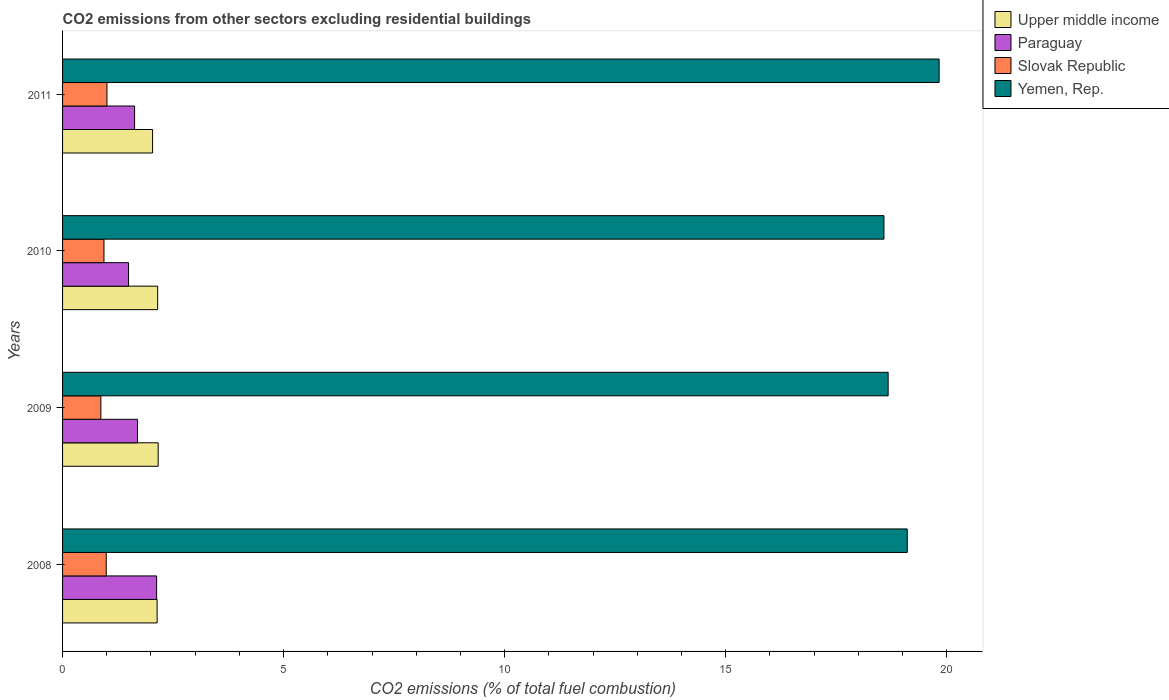Are the number of bars per tick equal to the number of legend labels?
Give a very brief answer. Yes. Are the number of bars on each tick of the Y-axis equal?
Provide a succinct answer. Yes. How many bars are there on the 1st tick from the top?
Keep it short and to the point. 4. How many bars are there on the 2nd tick from the bottom?
Keep it short and to the point. 4. What is the total CO2 emitted in Yemen, Rep. in 2009?
Provide a succinct answer. 18.68. Across all years, what is the maximum total CO2 emitted in Upper middle income?
Give a very brief answer. 2.16. Across all years, what is the minimum total CO2 emitted in Yemen, Rep.?
Make the answer very short. 18.58. In which year was the total CO2 emitted in Paraguay maximum?
Your response must be concise. 2008. What is the total total CO2 emitted in Slovak Republic in the graph?
Give a very brief answer. 3.79. What is the difference between the total CO2 emitted in Slovak Republic in 2010 and that in 2011?
Provide a short and direct response. -0.07. What is the difference between the total CO2 emitted in Upper middle income in 2010 and the total CO2 emitted in Paraguay in 2011?
Your response must be concise. 0.52. What is the average total CO2 emitted in Upper middle income per year?
Your answer should be compact. 2.12. In the year 2009, what is the difference between the total CO2 emitted in Paraguay and total CO2 emitted in Yemen, Rep.?
Offer a terse response. -16.98. What is the ratio of the total CO2 emitted in Upper middle income in 2008 to that in 2011?
Keep it short and to the point. 1.05. What is the difference between the highest and the second highest total CO2 emitted in Paraguay?
Provide a short and direct response. 0.43. What is the difference between the highest and the lowest total CO2 emitted in Upper middle income?
Keep it short and to the point. 0.13. In how many years, is the total CO2 emitted in Slovak Republic greater than the average total CO2 emitted in Slovak Republic taken over all years?
Offer a very short reply. 2. Is the sum of the total CO2 emitted in Yemen, Rep. in 2008 and 2009 greater than the maximum total CO2 emitted in Upper middle income across all years?
Provide a succinct answer. Yes. Is it the case that in every year, the sum of the total CO2 emitted in Slovak Republic and total CO2 emitted in Upper middle income is greater than the sum of total CO2 emitted in Paraguay and total CO2 emitted in Yemen, Rep.?
Provide a short and direct response. No. What does the 3rd bar from the top in 2011 represents?
Your answer should be compact. Paraguay. What does the 1st bar from the bottom in 2011 represents?
Make the answer very short. Upper middle income. Are the values on the major ticks of X-axis written in scientific E-notation?
Your answer should be very brief. No. Does the graph contain grids?
Give a very brief answer. No. What is the title of the graph?
Provide a short and direct response. CO2 emissions from other sectors excluding residential buildings. Does "American Samoa" appear as one of the legend labels in the graph?
Your answer should be compact. No. What is the label or title of the X-axis?
Give a very brief answer. CO2 emissions (% of total fuel combustion). What is the label or title of the Y-axis?
Your answer should be very brief. Years. What is the CO2 emissions (% of total fuel combustion) of Upper middle income in 2008?
Your answer should be compact. 2.14. What is the CO2 emissions (% of total fuel combustion) of Paraguay in 2008?
Your answer should be very brief. 2.13. What is the CO2 emissions (% of total fuel combustion) in Slovak Republic in 2008?
Provide a succinct answer. 0.99. What is the CO2 emissions (% of total fuel combustion) in Yemen, Rep. in 2008?
Give a very brief answer. 19.11. What is the CO2 emissions (% of total fuel combustion) of Upper middle income in 2009?
Offer a terse response. 2.16. What is the CO2 emissions (% of total fuel combustion) of Paraguay in 2009?
Give a very brief answer. 1.69. What is the CO2 emissions (% of total fuel combustion) in Slovak Republic in 2009?
Your answer should be compact. 0.87. What is the CO2 emissions (% of total fuel combustion) of Yemen, Rep. in 2009?
Ensure brevity in your answer.  18.68. What is the CO2 emissions (% of total fuel combustion) of Upper middle income in 2010?
Provide a short and direct response. 2.15. What is the CO2 emissions (% of total fuel combustion) in Paraguay in 2010?
Provide a succinct answer. 1.49. What is the CO2 emissions (% of total fuel combustion) of Slovak Republic in 2010?
Offer a terse response. 0.94. What is the CO2 emissions (% of total fuel combustion) of Yemen, Rep. in 2010?
Provide a short and direct response. 18.58. What is the CO2 emissions (% of total fuel combustion) of Upper middle income in 2011?
Your response must be concise. 2.04. What is the CO2 emissions (% of total fuel combustion) of Paraguay in 2011?
Your answer should be very brief. 1.63. What is the CO2 emissions (% of total fuel combustion) of Slovak Republic in 2011?
Keep it short and to the point. 1. What is the CO2 emissions (% of total fuel combustion) of Yemen, Rep. in 2011?
Give a very brief answer. 19.83. Across all years, what is the maximum CO2 emissions (% of total fuel combustion) of Upper middle income?
Ensure brevity in your answer.  2.16. Across all years, what is the maximum CO2 emissions (% of total fuel combustion) in Paraguay?
Provide a succinct answer. 2.13. Across all years, what is the maximum CO2 emissions (% of total fuel combustion) in Slovak Republic?
Your answer should be very brief. 1. Across all years, what is the maximum CO2 emissions (% of total fuel combustion) in Yemen, Rep.?
Give a very brief answer. 19.83. Across all years, what is the minimum CO2 emissions (% of total fuel combustion) of Upper middle income?
Your answer should be very brief. 2.04. Across all years, what is the minimum CO2 emissions (% of total fuel combustion) of Paraguay?
Give a very brief answer. 1.49. Across all years, what is the minimum CO2 emissions (% of total fuel combustion) in Slovak Republic?
Your response must be concise. 0.87. Across all years, what is the minimum CO2 emissions (% of total fuel combustion) in Yemen, Rep.?
Provide a succinct answer. 18.58. What is the total CO2 emissions (% of total fuel combustion) in Upper middle income in the graph?
Provide a succinct answer. 8.49. What is the total CO2 emissions (% of total fuel combustion) of Paraguay in the graph?
Provide a short and direct response. 6.94. What is the total CO2 emissions (% of total fuel combustion) of Slovak Republic in the graph?
Ensure brevity in your answer.  3.79. What is the total CO2 emissions (% of total fuel combustion) in Yemen, Rep. in the graph?
Offer a very short reply. 76.19. What is the difference between the CO2 emissions (% of total fuel combustion) in Upper middle income in 2008 and that in 2009?
Provide a short and direct response. -0.02. What is the difference between the CO2 emissions (% of total fuel combustion) of Paraguay in 2008 and that in 2009?
Keep it short and to the point. 0.43. What is the difference between the CO2 emissions (% of total fuel combustion) of Slovak Republic in 2008 and that in 2009?
Provide a short and direct response. 0.12. What is the difference between the CO2 emissions (% of total fuel combustion) in Yemen, Rep. in 2008 and that in 2009?
Ensure brevity in your answer.  0.43. What is the difference between the CO2 emissions (% of total fuel combustion) of Upper middle income in 2008 and that in 2010?
Provide a succinct answer. -0.01. What is the difference between the CO2 emissions (% of total fuel combustion) of Paraguay in 2008 and that in 2010?
Offer a very short reply. 0.64. What is the difference between the CO2 emissions (% of total fuel combustion) in Slovak Republic in 2008 and that in 2010?
Your answer should be compact. 0.05. What is the difference between the CO2 emissions (% of total fuel combustion) in Yemen, Rep. in 2008 and that in 2010?
Offer a terse response. 0.53. What is the difference between the CO2 emissions (% of total fuel combustion) of Upper middle income in 2008 and that in 2011?
Offer a very short reply. 0.1. What is the difference between the CO2 emissions (% of total fuel combustion) of Paraguay in 2008 and that in 2011?
Make the answer very short. 0.5. What is the difference between the CO2 emissions (% of total fuel combustion) of Slovak Republic in 2008 and that in 2011?
Give a very brief answer. -0.02. What is the difference between the CO2 emissions (% of total fuel combustion) of Yemen, Rep. in 2008 and that in 2011?
Offer a very short reply. -0.72. What is the difference between the CO2 emissions (% of total fuel combustion) in Upper middle income in 2009 and that in 2010?
Provide a succinct answer. 0.01. What is the difference between the CO2 emissions (% of total fuel combustion) in Paraguay in 2009 and that in 2010?
Provide a succinct answer. 0.2. What is the difference between the CO2 emissions (% of total fuel combustion) in Slovak Republic in 2009 and that in 2010?
Offer a terse response. -0.07. What is the difference between the CO2 emissions (% of total fuel combustion) in Yemen, Rep. in 2009 and that in 2010?
Give a very brief answer. 0.09. What is the difference between the CO2 emissions (% of total fuel combustion) in Upper middle income in 2009 and that in 2011?
Ensure brevity in your answer.  0.13. What is the difference between the CO2 emissions (% of total fuel combustion) in Paraguay in 2009 and that in 2011?
Your answer should be compact. 0.07. What is the difference between the CO2 emissions (% of total fuel combustion) of Slovak Republic in 2009 and that in 2011?
Make the answer very short. -0.14. What is the difference between the CO2 emissions (% of total fuel combustion) in Yemen, Rep. in 2009 and that in 2011?
Your response must be concise. -1.15. What is the difference between the CO2 emissions (% of total fuel combustion) in Upper middle income in 2010 and that in 2011?
Give a very brief answer. 0.11. What is the difference between the CO2 emissions (% of total fuel combustion) of Paraguay in 2010 and that in 2011?
Offer a terse response. -0.14. What is the difference between the CO2 emissions (% of total fuel combustion) of Slovak Republic in 2010 and that in 2011?
Make the answer very short. -0.07. What is the difference between the CO2 emissions (% of total fuel combustion) of Yemen, Rep. in 2010 and that in 2011?
Your answer should be very brief. -1.25. What is the difference between the CO2 emissions (% of total fuel combustion) of Upper middle income in 2008 and the CO2 emissions (% of total fuel combustion) of Paraguay in 2009?
Your answer should be very brief. 0.44. What is the difference between the CO2 emissions (% of total fuel combustion) in Upper middle income in 2008 and the CO2 emissions (% of total fuel combustion) in Slovak Republic in 2009?
Your answer should be compact. 1.27. What is the difference between the CO2 emissions (% of total fuel combustion) in Upper middle income in 2008 and the CO2 emissions (% of total fuel combustion) in Yemen, Rep. in 2009?
Ensure brevity in your answer.  -16.54. What is the difference between the CO2 emissions (% of total fuel combustion) in Paraguay in 2008 and the CO2 emissions (% of total fuel combustion) in Slovak Republic in 2009?
Your answer should be very brief. 1.26. What is the difference between the CO2 emissions (% of total fuel combustion) in Paraguay in 2008 and the CO2 emissions (% of total fuel combustion) in Yemen, Rep. in 2009?
Give a very brief answer. -16.55. What is the difference between the CO2 emissions (% of total fuel combustion) of Slovak Republic in 2008 and the CO2 emissions (% of total fuel combustion) of Yemen, Rep. in 2009?
Give a very brief answer. -17.69. What is the difference between the CO2 emissions (% of total fuel combustion) of Upper middle income in 2008 and the CO2 emissions (% of total fuel combustion) of Paraguay in 2010?
Provide a succinct answer. 0.65. What is the difference between the CO2 emissions (% of total fuel combustion) in Upper middle income in 2008 and the CO2 emissions (% of total fuel combustion) in Slovak Republic in 2010?
Offer a very short reply. 1.2. What is the difference between the CO2 emissions (% of total fuel combustion) in Upper middle income in 2008 and the CO2 emissions (% of total fuel combustion) in Yemen, Rep. in 2010?
Provide a short and direct response. -16.44. What is the difference between the CO2 emissions (% of total fuel combustion) of Paraguay in 2008 and the CO2 emissions (% of total fuel combustion) of Slovak Republic in 2010?
Provide a succinct answer. 1.19. What is the difference between the CO2 emissions (% of total fuel combustion) in Paraguay in 2008 and the CO2 emissions (% of total fuel combustion) in Yemen, Rep. in 2010?
Your answer should be compact. -16.45. What is the difference between the CO2 emissions (% of total fuel combustion) in Slovak Republic in 2008 and the CO2 emissions (% of total fuel combustion) in Yemen, Rep. in 2010?
Offer a terse response. -17.59. What is the difference between the CO2 emissions (% of total fuel combustion) of Upper middle income in 2008 and the CO2 emissions (% of total fuel combustion) of Paraguay in 2011?
Your response must be concise. 0.51. What is the difference between the CO2 emissions (% of total fuel combustion) in Upper middle income in 2008 and the CO2 emissions (% of total fuel combustion) in Slovak Republic in 2011?
Provide a short and direct response. 1.13. What is the difference between the CO2 emissions (% of total fuel combustion) of Upper middle income in 2008 and the CO2 emissions (% of total fuel combustion) of Yemen, Rep. in 2011?
Offer a terse response. -17.69. What is the difference between the CO2 emissions (% of total fuel combustion) in Paraguay in 2008 and the CO2 emissions (% of total fuel combustion) in Slovak Republic in 2011?
Ensure brevity in your answer.  1.12. What is the difference between the CO2 emissions (% of total fuel combustion) in Paraguay in 2008 and the CO2 emissions (% of total fuel combustion) in Yemen, Rep. in 2011?
Offer a terse response. -17.7. What is the difference between the CO2 emissions (% of total fuel combustion) of Slovak Republic in 2008 and the CO2 emissions (% of total fuel combustion) of Yemen, Rep. in 2011?
Provide a short and direct response. -18.84. What is the difference between the CO2 emissions (% of total fuel combustion) in Upper middle income in 2009 and the CO2 emissions (% of total fuel combustion) in Paraguay in 2010?
Provide a succinct answer. 0.67. What is the difference between the CO2 emissions (% of total fuel combustion) in Upper middle income in 2009 and the CO2 emissions (% of total fuel combustion) in Slovak Republic in 2010?
Make the answer very short. 1.23. What is the difference between the CO2 emissions (% of total fuel combustion) in Upper middle income in 2009 and the CO2 emissions (% of total fuel combustion) in Yemen, Rep. in 2010?
Your response must be concise. -16.42. What is the difference between the CO2 emissions (% of total fuel combustion) in Paraguay in 2009 and the CO2 emissions (% of total fuel combustion) in Slovak Republic in 2010?
Provide a succinct answer. 0.76. What is the difference between the CO2 emissions (% of total fuel combustion) in Paraguay in 2009 and the CO2 emissions (% of total fuel combustion) in Yemen, Rep. in 2010?
Keep it short and to the point. -16.89. What is the difference between the CO2 emissions (% of total fuel combustion) of Slovak Republic in 2009 and the CO2 emissions (% of total fuel combustion) of Yemen, Rep. in 2010?
Make the answer very short. -17.71. What is the difference between the CO2 emissions (% of total fuel combustion) of Upper middle income in 2009 and the CO2 emissions (% of total fuel combustion) of Paraguay in 2011?
Offer a terse response. 0.53. What is the difference between the CO2 emissions (% of total fuel combustion) of Upper middle income in 2009 and the CO2 emissions (% of total fuel combustion) of Slovak Republic in 2011?
Provide a short and direct response. 1.16. What is the difference between the CO2 emissions (% of total fuel combustion) of Upper middle income in 2009 and the CO2 emissions (% of total fuel combustion) of Yemen, Rep. in 2011?
Provide a succinct answer. -17.67. What is the difference between the CO2 emissions (% of total fuel combustion) in Paraguay in 2009 and the CO2 emissions (% of total fuel combustion) in Slovak Republic in 2011?
Offer a terse response. 0.69. What is the difference between the CO2 emissions (% of total fuel combustion) of Paraguay in 2009 and the CO2 emissions (% of total fuel combustion) of Yemen, Rep. in 2011?
Your answer should be very brief. -18.13. What is the difference between the CO2 emissions (% of total fuel combustion) of Slovak Republic in 2009 and the CO2 emissions (% of total fuel combustion) of Yemen, Rep. in 2011?
Give a very brief answer. -18.96. What is the difference between the CO2 emissions (% of total fuel combustion) of Upper middle income in 2010 and the CO2 emissions (% of total fuel combustion) of Paraguay in 2011?
Provide a short and direct response. 0.52. What is the difference between the CO2 emissions (% of total fuel combustion) of Upper middle income in 2010 and the CO2 emissions (% of total fuel combustion) of Slovak Republic in 2011?
Offer a terse response. 1.15. What is the difference between the CO2 emissions (% of total fuel combustion) of Upper middle income in 2010 and the CO2 emissions (% of total fuel combustion) of Yemen, Rep. in 2011?
Provide a succinct answer. -17.68. What is the difference between the CO2 emissions (% of total fuel combustion) in Paraguay in 2010 and the CO2 emissions (% of total fuel combustion) in Slovak Republic in 2011?
Ensure brevity in your answer.  0.49. What is the difference between the CO2 emissions (% of total fuel combustion) in Paraguay in 2010 and the CO2 emissions (% of total fuel combustion) in Yemen, Rep. in 2011?
Offer a very short reply. -18.34. What is the difference between the CO2 emissions (% of total fuel combustion) in Slovak Republic in 2010 and the CO2 emissions (% of total fuel combustion) in Yemen, Rep. in 2011?
Your response must be concise. -18.89. What is the average CO2 emissions (% of total fuel combustion) in Upper middle income per year?
Provide a short and direct response. 2.12. What is the average CO2 emissions (% of total fuel combustion) in Paraguay per year?
Offer a very short reply. 1.74. What is the average CO2 emissions (% of total fuel combustion) of Slovak Republic per year?
Offer a terse response. 0.95. What is the average CO2 emissions (% of total fuel combustion) in Yemen, Rep. per year?
Provide a succinct answer. 19.05. In the year 2008, what is the difference between the CO2 emissions (% of total fuel combustion) of Upper middle income and CO2 emissions (% of total fuel combustion) of Paraguay?
Your answer should be compact. 0.01. In the year 2008, what is the difference between the CO2 emissions (% of total fuel combustion) in Upper middle income and CO2 emissions (% of total fuel combustion) in Slovak Republic?
Offer a very short reply. 1.15. In the year 2008, what is the difference between the CO2 emissions (% of total fuel combustion) of Upper middle income and CO2 emissions (% of total fuel combustion) of Yemen, Rep.?
Your answer should be very brief. -16.97. In the year 2008, what is the difference between the CO2 emissions (% of total fuel combustion) of Paraguay and CO2 emissions (% of total fuel combustion) of Slovak Republic?
Keep it short and to the point. 1.14. In the year 2008, what is the difference between the CO2 emissions (% of total fuel combustion) in Paraguay and CO2 emissions (% of total fuel combustion) in Yemen, Rep.?
Provide a succinct answer. -16.98. In the year 2008, what is the difference between the CO2 emissions (% of total fuel combustion) of Slovak Republic and CO2 emissions (% of total fuel combustion) of Yemen, Rep.?
Give a very brief answer. -18.12. In the year 2009, what is the difference between the CO2 emissions (% of total fuel combustion) in Upper middle income and CO2 emissions (% of total fuel combustion) in Paraguay?
Provide a succinct answer. 0.47. In the year 2009, what is the difference between the CO2 emissions (% of total fuel combustion) of Upper middle income and CO2 emissions (% of total fuel combustion) of Slovak Republic?
Your response must be concise. 1.3. In the year 2009, what is the difference between the CO2 emissions (% of total fuel combustion) of Upper middle income and CO2 emissions (% of total fuel combustion) of Yemen, Rep.?
Provide a succinct answer. -16.51. In the year 2009, what is the difference between the CO2 emissions (% of total fuel combustion) of Paraguay and CO2 emissions (% of total fuel combustion) of Slovak Republic?
Offer a terse response. 0.83. In the year 2009, what is the difference between the CO2 emissions (% of total fuel combustion) in Paraguay and CO2 emissions (% of total fuel combustion) in Yemen, Rep.?
Your answer should be compact. -16.98. In the year 2009, what is the difference between the CO2 emissions (% of total fuel combustion) of Slovak Republic and CO2 emissions (% of total fuel combustion) of Yemen, Rep.?
Your answer should be compact. -17.81. In the year 2010, what is the difference between the CO2 emissions (% of total fuel combustion) of Upper middle income and CO2 emissions (% of total fuel combustion) of Paraguay?
Provide a short and direct response. 0.66. In the year 2010, what is the difference between the CO2 emissions (% of total fuel combustion) of Upper middle income and CO2 emissions (% of total fuel combustion) of Slovak Republic?
Provide a short and direct response. 1.21. In the year 2010, what is the difference between the CO2 emissions (% of total fuel combustion) of Upper middle income and CO2 emissions (% of total fuel combustion) of Yemen, Rep.?
Ensure brevity in your answer.  -16.43. In the year 2010, what is the difference between the CO2 emissions (% of total fuel combustion) of Paraguay and CO2 emissions (% of total fuel combustion) of Slovak Republic?
Offer a terse response. 0.56. In the year 2010, what is the difference between the CO2 emissions (% of total fuel combustion) in Paraguay and CO2 emissions (% of total fuel combustion) in Yemen, Rep.?
Your response must be concise. -17.09. In the year 2010, what is the difference between the CO2 emissions (% of total fuel combustion) of Slovak Republic and CO2 emissions (% of total fuel combustion) of Yemen, Rep.?
Provide a succinct answer. -17.64. In the year 2011, what is the difference between the CO2 emissions (% of total fuel combustion) of Upper middle income and CO2 emissions (% of total fuel combustion) of Paraguay?
Your answer should be very brief. 0.41. In the year 2011, what is the difference between the CO2 emissions (% of total fuel combustion) in Upper middle income and CO2 emissions (% of total fuel combustion) in Slovak Republic?
Your answer should be compact. 1.03. In the year 2011, what is the difference between the CO2 emissions (% of total fuel combustion) of Upper middle income and CO2 emissions (% of total fuel combustion) of Yemen, Rep.?
Your answer should be compact. -17.79. In the year 2011, what is the difference between the CO2 emissions (% of total fuel combustion) in Paraguay and CO2 emissions (% of total fuel combustion) in Slovak Republic?
Give a very brief answer. 0.63. In the year 2011, what is the difference between the CO2 emissions (% of total fuel combustion) of Paraguay and CO2 emissions (% of total fuel combustion) of Yemen, Rep.?
Ensure brevity in your answer.  -18.2. In the year 2011, what is the difference between the CO2 emissions (% of total fuel combustion) of Slovak Republic and CO2 emissions (% of total fuel combustion) of Yemen, Rep.?
Ensure brevity in your answer.  -18.82. What is the ratio of the CO2 emissions (% of total fuel combustion) in Upper middle income in 2008 to that in 2009?
Your response must be concise. 0.99. What is the ratio of the CO2 emissions (% of total fuel combustion) in Paraguay in 2008 to that in 2009?
Offer a terse response. 1.26. What is the ratio of the CO2 emissions (% of total fuel combustion) in Slovak Republic in 2008 to that in 2009?
Ensure brevity in your answer.  1.14. What is the ratio of the CO2 emissions (% of total fuel combustion) in Yemen, Rep. in 2008 to that in 2009?
Give a very brief answer. 1.02. What is the ratio of the CO2 emissions (% of total fuel combustion) in Paraguay in 2008 to that in 2010?
Give a very brief answer. 1.43. What is the ratio of the CO2 emissions (% of total fuel combustion) of Slovak Republic in 2008 to that in 2010?
Provide a short and direct response. 1.05. What is the ratio of the CO2 emissions (% of total fuel combustion) of Yemen, Rep. in 2008 to that in 2010?
Provide a short and direct response. 1.03. What is the ratio of the CO2 emissions (% of total fuel combustion) of Upper middle income in 2008 to that in 2011?
Offer a terse response. 1.05. What is the ratio of the CO2 emissions (% of total fuel combustion) in Paraguay in 2008 to that in 2011?
Offer a terse response. 1.31. What is the ratio of the CO2 emissions (% of total fuel combustion) of Slovak Republic in 2008 to that in 2011?
Provide a short and direct response. 0.98. What is the ratio of the CO2 emissions (% of total fuel combustion) of Yemen, Rep. in 2008 to that in 2011?
Provide a succinct answer. 0.96. What is the ratio of the CO2 emissions (% of total fuel combustion) of Upper middle income in 2009 to that in 2010?
Offer a very short reply. 1.01. What is the ratio of the CO2 emissions (% of total fuel combustion) in Paraguay in 2009 to that in 2010?
Provide a succinct answer. 1.14. What is the ratio of the CO2 emissions (% of total fuel combustion) of Slovak Republic in 2009 to that in 2010?
Provide a short and direct response. 0.93. What is the ratio of the CO2 emissions (% of total fuel combustion) of Yemen, Rep. in 2009 to that in 2010?
Offer a very short reply. 1.01. What is the ratio of the CO2 emissions (% of total fuel combustion) of Upper middle income in 2009 to that in 2011?
Give a very brief answer. 1.06. What is the ratio of the CO2 emissions (% of total fuel combustion) of Paraguay in 2009 to that in 2011?
Ensure brevity in your answer.  1.04. What is the ratio of the CO2 emissions (% of total fuel combustion) in Slovak Republic in 2009 to that in 2011?
Ensure brevity in your answer.  0.86. What is the ratio of the CO2 emissions (% of total fuel combustion) in Yemen, Rep. in 2009 to that in 2011?
Ensure brevity in your answer.  0.94. What is the ratio of the CO2 emissions (% of total fuel combustion) of Upper middle income in 2010 to that in 2011?
Offer a very short reply. 1.06. What is the ratio of the CO2 emissions (% of total fuel combustion) in Paraguay in 2010 to that in 2011?
Your answer should be very brief. 0.92. What is the ratio of the CO2 emissions (% of total fuel combustion) of Slovak Republic in 2010 to that in 2011?
Provide a succinct answer. 0.93. What is the ratio of the CO2 emissions (% of total fuel combustion) in Yemen, Rep. in 2010 to that in 2011?
Ensure brevity in your answer.  0.94. What is the difference between the highest and the second highest CO2 emissions (% of total fuel combustion) in Upper middle income?
Offer a very short reply. 0.01. What is the difference between the highest and the second highest CO2 emissions (% of total fuel combustion) in Paraguay?
Keep it short and to the point. 0.43. What is the difference between the highest and the second highest CO2 emissions (% of total fuel combustion) in Slovak Republic?
Offer a very short reply. 0.02. What is the difference between the highest and the second highest CO2 emissions (% of total fuel combustion) in Yemen, Rep.?
Ensure brevity in your answer.  0.72. What is the difference between the highest and the lowest CO2 emissions (% of total fuel combustion) in Upper middle income?
Your answer should be very brief. 0.13. What is the difference between the highest and the lowest CO2 emissions (% of total fuel combustion) in Paraguay?
Offer a terse response. 0.64. What is the difference between the highest and the lowest CO2 emissions (% of total fuel combustion) in Slovak Republic?
Your answer should be very brief. 0.14. What is the difference between the highest and the lowest CO2 emissions (% of total fuel combustion) in Yemen, Rep.?
Offer a very short reply. 1.25. 